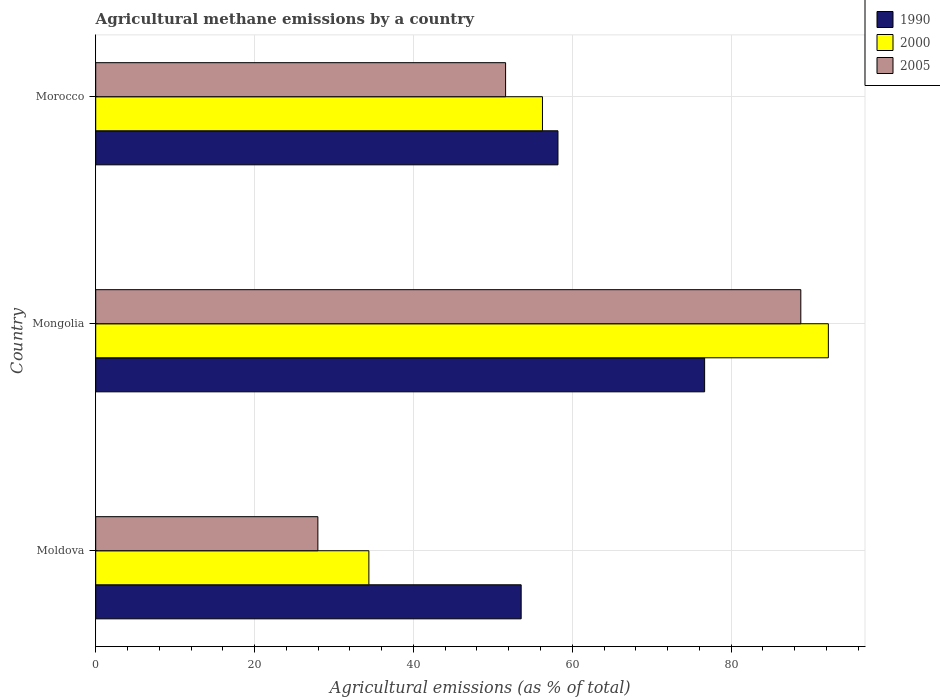How many groups of bars are there?
Your answer should be very brief. 3. How many bars are there on the 3rd tick from the bottom?
Keep it short and to the point. 3. What is the label of the 1st group of bars from the top?
Provide a succinct answer. Morocco. In how many cases, is the number of bars for a given country not equal to the number of legend labels?
Your response must be concise. 0. What is the amount of agricultural methane emitted in 1990 in Moldova?
Offer a very short reply. 53.56. Across all countries, what is the maximum amount of agricultural methane emitted in 2000?
Make the answer very short. 92.24. Across all countries, what is the minimum amount of agricultural methane emitted in 2000?
Give a very brief answer. 34.39. In which country was the amount of agricultural methane emitted in 2000 maximum?
Give a very brief answer. Mongolia. In which country was the amount of agricultural methane emitted in 2000 minimum?
Provide a succinct answer. Moldova. What is the total amount of agricultural methane emitted in 2005 in the graph?
Give a very brief answer. 168.34. What is the difference between the amount of agricultural methane emitted in 2000 in Moldova and that in Mongolia?
Your answer should be compact. -57.85. What is the difference between the amount of agricultural methane emitted in 2005 in Mongolia and the amount of agricultural methane emitted in 1990 in Morocco?
Provide a succinct answer. 30.57. What is the average amount of agricultural methane emitted in 2000 per country?
Your answer should be compact. 60.96. What is the difference between the amount of agricultural methane emitted in 1990 and amount of agricultural methane emitted in 2000 in Mongolia?
Provide a short and direct response. -15.58. What is the ratio of the amount of agricultural methane emitted in 2005 in Moldova to that in Mongolia?
Offer a terse response. 0.32. Is the difference between the amount of agricultural methane emitted in 1990 in Mongolia and Morocco greater than the difference between the amount of agricultural methane emitted in 2000 in Mongolia and Morocco?
Ensure brevity in your answer.  No. What is the difference between the highest and the second highest amount of agricultural methane emitted in 1990?
Ensure brevity in your answer.  18.46. What is the difference between the highest and the lowest amount of agricultural methane emitted in 2005?
Your answer should be very brief. 60.8. In how many countries, is the amount of agricultural methane emitted in 2005 greater than the average amount of agricultural methane emitted in 2005 taken over all countries?
Give a very brief answer. 1. What does the 3rd bar from the top in Moldova represents?
Offer a very short reply. 1990. What does the 1st bar from the bottom in Morocco represents?
Your response must be concise. 1990. Is it the case that in every country, the sum of the amount of agricultural methane emitted in 2005 and amount of agricultural methane emitted in 1990 is greater than the amount of agricultural methane emitted in 2000?
Your response must be concise. Yes. Are all the bars in the graph horizontal?
Offer a terse response. Yes. How many countries are there in the graph?
Your answer should be very brief. 3. Are the values on the major ticks of X-axis written in scientific E-notation?
Provide a succinct answer. No. Where does the legend appear in the graph?
Make the answer very short. Top right. How are the legend labels stacked?
Ensure brevity in your answer.  Vertical. What is the title of the graph?
Keep it short and to the point. Agricultural methane emissions by a country. Does "1987" appear as one of the legend labels in the graph?
Provide a short and direct response. No. What is the label or title of the X-axis?
Offer a very short reply. Agricultural emissions (as % of total). What is the Agricultural emissions (as % of total) of 1990 in Moldova?
Your answer should be compact. 53.56. What is the Agricultural emissions (as % of total) of 2000 in Moldova?
Keep it short and to the point. 34.39. What is the Agricultural emissions (as % of total) in 2005 in Moldova?
Give a very brief answer. 27.97. What is the Agricultural emissions (as % of total) of 1990 in Mongolia?
Provide a short and direct response. 76.66. What is the Agricultural emissions (as % of total) in 2000 in Mongolia?
Provide a short and direct response. 92.24. What is the Agricultural emissions (as % of total) of 2005 in Mongolia?
Your answer should be very brief. 88.77. What is the Agricultural emissions (as % of total) in 1990 in Morocco?
Make the answer very short. 58.2. What is the Agricultural emissions (as % of total) of 2000 in Morocco?
Your answer should be very brief. 56.24. What is the Agricultural emissions (as % of total) of 2005 in Morocco?
Provide a short and direct response. 51.6. Across all countries, what is the maximum Agricultural emissions (as % of total) of 1990?
Provide a short and direct response. 76.66. Across all countries, what is the maximum Agricultural emissions (as % of total) of 2000?
Your answer should be very brief. 92.24. Across all countries, what is the maximum Agricultural emissions (as % of total) in 2005?
Your response must be concise. 88.77. Across all countries, what is the minimum Agricultural emissions (as % of total) of 1990?
Provide a short and direct response. 53.56. Across all countries, what is the minimum Agricultural emissions (as % of total) in 2000?
Offer a terse response. 34.39. Across all countries, what is the minimum Agricultural emissions (as % of total) of 2005?
Your answer should be compact. 27.97. What is the total Agricultural emissions (as % of total) of 1990 in the graph?
Your answer should be very brief. 188.42. What is the total Agricultural emissions (as % of total) in 2000 in the graph?
Your answer should be compact. 182.87. What is the total Agricultural emissions (as % of total) in 2005 in the graph?
Keep it short and to the point. 168.34. What is the difference between the Agricultural emissions (as % of total) of 1990 in Moldova and that in Mongolia?
Your response must be concise. -23.1. What is the difference between the Agricultural emissions (as % of total) of 2000 in Moldova and that in Mongolia?
Make the answer very short. -57.85. What is the difference between the Agricultural emissions (as % of total) in 2005 in Moldova and that in Mongolia?
Your answer should be very brief. -60.8. What is the difference between the Agricultural emissions (as % of total) in 1990 in Moldova and that in Morocco?
Provide a succinct answer. -4.63. What is the difference between the Agricultural emissions (as % of total) of 2000 in Moldova and that in Morocco?
Offer a very short reply. -21.85. What is the difference between the Agricultural emissions (as % of total) in 2005 in Moldova and that in Morocco?
Offer a very short reply. -23.63. What is the difference between the Agricultural emissions (as % of total) in 1990 in Mongolia and that in Morocco?
Provide a succinct answer. 18.46. What is the difference between the Agricultural emissions (as % of total) in 2000 in Mongolia and that in Morocco?
Your answer should be very brief. 35.99. What is the difference between the Agricultural emissions (as % of total) of 2005 in Mongolia and that in Morocco?
Give a very brief answer. 37.17. What is the difference between the Agricultural emissions (as % of total) of 1990 in Moldova and the Agricultural emissions (as % of total) of 2000 in Mongolia?
Make the answer very short. -38.67. What is the difference between the Agricultural emissions (as % of total) of 1990 in Moldova and the Agricultural emissions (as % of total) of 2005 in Mongolia?
Make the answer very short. -35.21. What is the difference between the Agricultural emissions (as % of total) of 2000 in Moldova and the Agricultural emissions (as % of total) of 2005 in Mongolia?
Your response must be concise. -54.38. What is the difference between the Agricultural emissions (as % of total) of 1990 in Moldova and the Agricultural emissions (as % of total) of 2000 in Morocco?
Keep it short and to the point. -2.68. What is the difference between the Agricultural emissions (as % of total) in 1990 in Moldova and the Agricultural emissions (as % of total) in 2005 in Morocco?
Provide a short and direct response. 1.96. What is the difference between the Agricultural emissions (as % of total) in 2000 in Moldova and the Agricultural emissions (as % of total) in 2005 in Morocco?
Your answer should be very brief. -17.21. What is the difference between the Agricultural emissions (as % of total) of 1990 in Mongolia and the Agricultural emissions (as % of total) of 2000 in Morocco?
Offer a terse response. 20.42. What is the difference between the Agricultural emissions (as % of total) of 1990 in Mongolia and the Agricultural emissions (as % of total) of 2005 in Morocco?
Ensure brevity in your answer.  25.06. What is the difference between the Agricultural emissions (as % of total) of 2000 in Mongolia and the Agricultural emissions (as % of total) of 2005 in Morocco?
Your answer should be compact. 40.63. What is the average Agricultural emissions (as % of total) of 1990 per country?
Your response must be concise. 62.81. What is the average Agricultural emissions (as % of total) of 2000 per country?
Your answer should be very brief. 60.96. What is the average Agricultural emissions (as % of total) of 2005 per country?
Offer a terse response. 56.11. What is the difference between the Agricultural emissions (as % of total) of 1990 and Agricultural emissions (as % of total) of 2000 in Moldova?
Your answer should be very brief. 19.17. What is the difference between the Agricultural emissions (as % of total) in 1990 and Agricultural emissions (as % of total) in 2005 in Moldova?
Your answer should be very brief. 25.59. What is the difference between the Agricultural emissions (as % of total) of 2000 and Agricultural emissions (as % of total) of 2005 in Moldova?
Give a very brief answer. 6.42. What is the difference between the Agricultural emissions (as % of total) of 1990 and Agricultural emissions (as % of total) of 2000 in Mongolia?
Provide a short and direct response. -15.58. What is the difference between the Agricultural emissions (as % of total) of 1990 and Agricultural emissions (as % of total) of 2005 in Mongolia?
Provide a succinct answer. -12.11. What is the difference between the Agricultural emissions (as % of total) of 2000 and Agricultural emissions (as % of total) of 2005 in Mongolia?
Give a very brief answer. 3.47. What is the difference between the Agricultural emissions (as % of total) of 1990 and Agricultural emissions (as % of total) of 2000 in Morocco?
Your response must be concise. 1.95. What is the difference between the Agricultural emissions (as % of total) in 1990 and Agricultural emissions (as % of total) in 2005 in Morocco?
Offer a very short reply. 6.59. What is the difference between the Agricultural emissions (as % of total) in 2000 and Agricultural emissions (as % of total) in 2005 in Morocco?
Your answer should be very brief. 4.64. What is the ratio of the Agricultural emissions (as % of total) of 1990 in Moldova to that in Mongolia?
Keep it short and to the point. 0.7. What is the ratio of the Agricultural emissions (as % of total) of 2000 in Moldova to that in Mongolia?
Keep it short and to the point. 0.37. What is the ratio of the Agricultural emissions (as % of total) of 2005 in Moldova to that in Mongolia?
Offer a terse response. 0.32. What is the ratio of the Agricultural emissions (as % of total) in 1990 in Moldova to that in Morocco?
Ensure brevity in your answer.  0.92. What is the ratio of the Agricultural emissions (as % of total) of 2000 in Moldova to that in Morocco?
Make the answer very short. 0.61. What is the ratio of the Agricultural emissions (as % of total) in 2005 in Moldova to that in Morocco?
Make the answer very short. 0.54. What is the ratio of the Agricultural emissions (as % of total) in 1990 in Mongolia to that in Morocco?
Your answer should be compact. 1.32. What is the ratio of the Agricultural emissions (as % of total) in 2000 in Mongolia to that in Morocco?
Provide a succinct answer. 1.64. What is the ratio of the Agricultural emissions (as % of total) in 2005 in Mongolia to that in Morocco?
Offer a very short reply. 1.72. What is the difference between the highest and the second highest Agricultural emissions (as % of total) in 1990?
Your answer should be compact. 18.46. What is the difference between the highest and the second highest Agricultural emissions (as % of total) of 2000?
Provide a short and direct response. 35.99. What is the difference between the highest and the second highest Agricultural emissions (as % of total) of 2005?
Your response must be concise. 37.17. What is the difference between the highest and the lowest Agricultural emissions (as % of total) of 1990?
Offer a very short reply. 23.1. What is the difference between the highest and the lowest Agricultural emissions (as % of total) of 2000?
Your answer should be very brief. 57.85. What is the difference between the highest and the lowest Agricultural emissions (as % of total) in 2005?
Offer a very short reply. 60.8. 